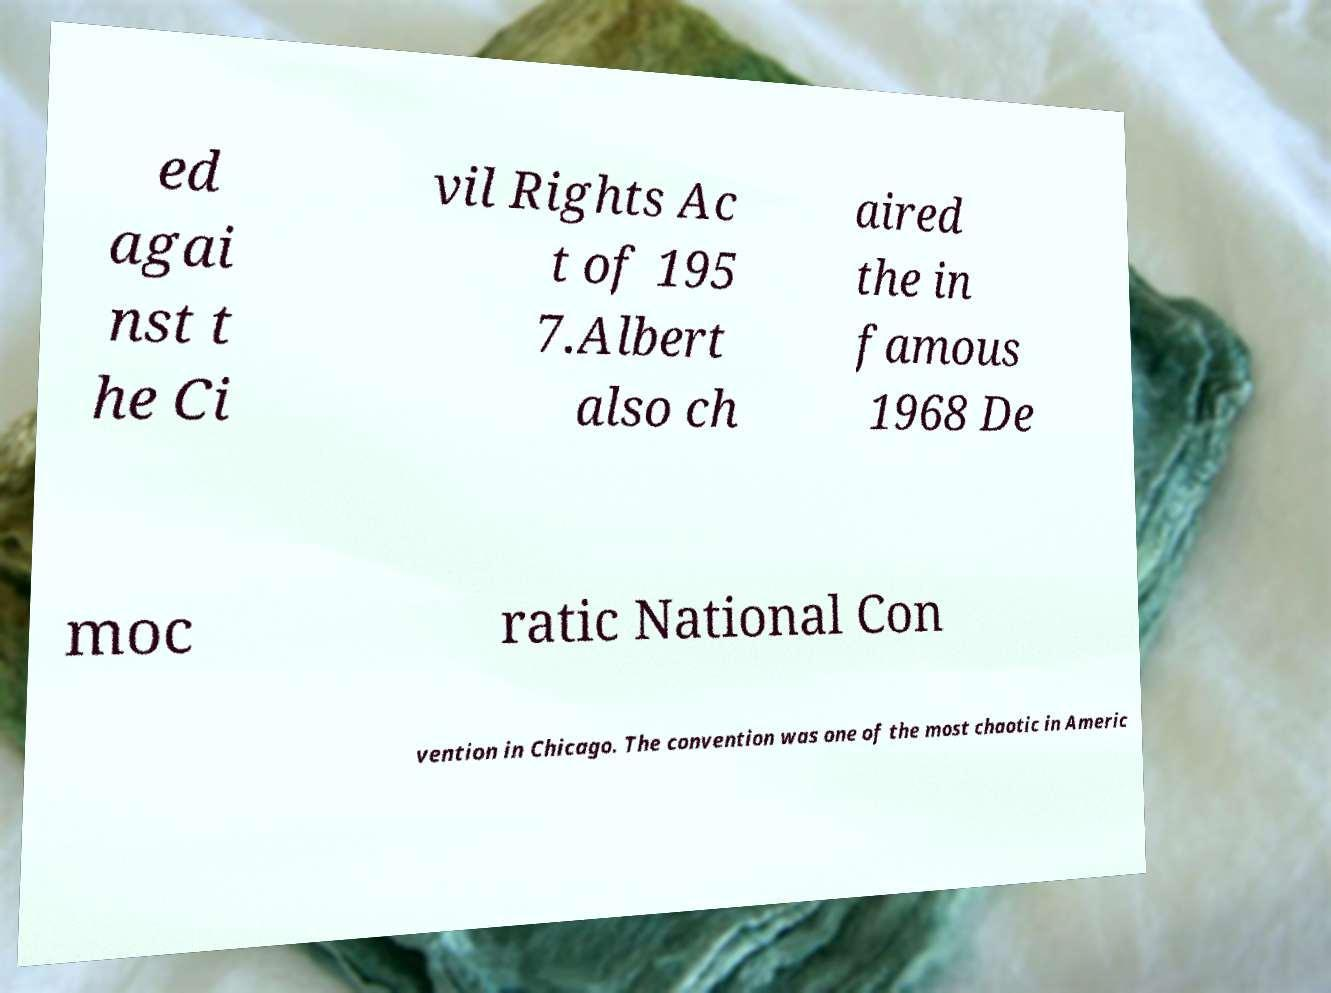Can you read and provide the text displayed in the image?This photo seems to have some interesting text. Can you extract and type it out for me? ed agai nst t he Ci vil Rights Ac t of 195 7.Albert also ch aired the in famous 1968 De moc ratic National Con vention in Chicago. The convention was one of the most chaotic in Americ 